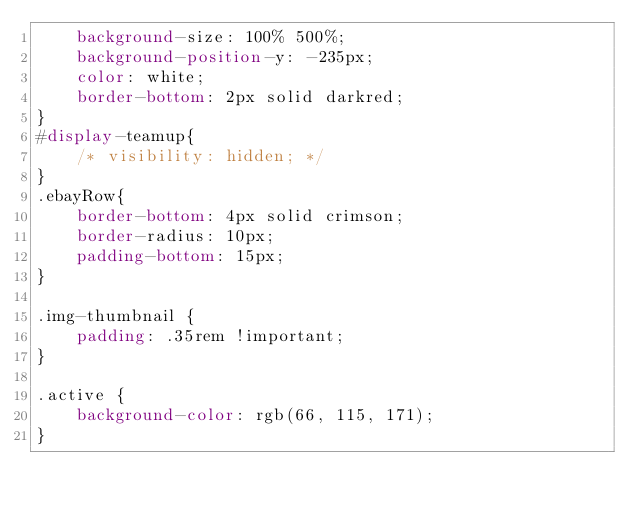<code> <loc_0><loc_0><loc_500><loc_500><_CSS_>    background-size: 100% 500%;
    background-position-y: -235px;
    color: white;
    border-bottom: 2px solid darkred;
}
#display-teamup{
    /* visibility: hidden; */
}
.ebayRow{
    border-bottom: 4px solid crimson;
    border-radius: 10px;
    padding-bottom: 15px;
}

.img-thumbnail {
    padding: .35rem !important;
}

.active {
    background-color: rgb(66, 115, 171);
}</code> 